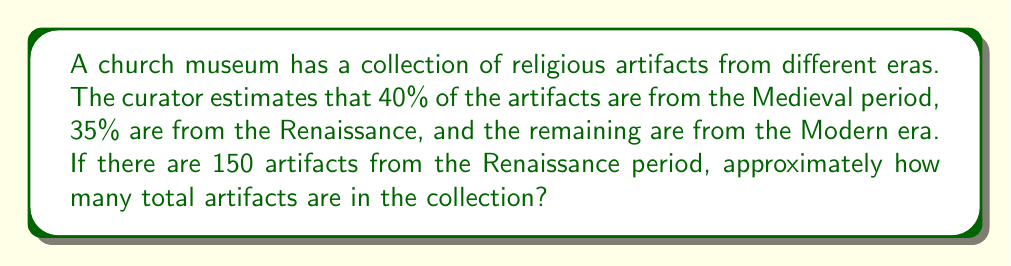Teach me how to tackle this problem. Let's approach this step-by-step:

1) We know that 35% of the total artifacts are from the Renaissance period.
2) We are given that there are 150 Renaissance artifacts.
3) Let's call the total number of artifacts $x$.

   So, we can set up the equation:
   $$ 0.35x = 150 $$

4) To solve for $x$, we divide both sides by 0.35:
   $$ x = \frac{150}{0.35} $$

5) Calculating this:
   $$ x = 428.57... $$

6) Since we're dealing with whole artifacts, we need to round to the nearest whole number.

Therefore, there are approximately 429 total artifacts in the collection.

To verify:
- Medieval (40%): $429 \times 0.40 \approx 172$ artifacts
- Renaissance (35%): $429 \times 0.35 \approx 150$ artifacts (matches given information)
- Modern (remaining 25%): $429 \times 0.25 \approx 107$ artifacts

$172 + 150 + 107 = 429$, which confirms our calculation.
Answer: 429 artifacts 